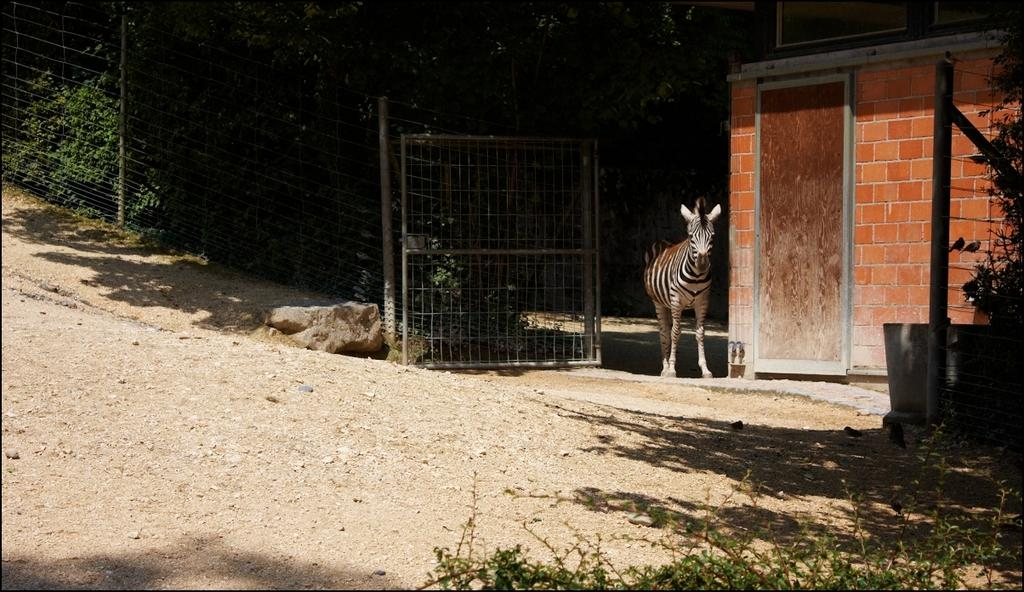What type of animal can be seen in the image? There is a zebra in the image. What other natural elements are present in the image? There are plants, trees, and rocks in the image. What type of structure is visible in the image? There is a house in the image. What man-made features can be seen in the image? There is a fence, gate, pole, and door in the image. What type of coat is the farmer wearing in the image? There is no farmer present in the image, and therefore no coat can be observed. Is the zebra wearing a veil in the image? No, the zebra is not wearing a veil in the image. 